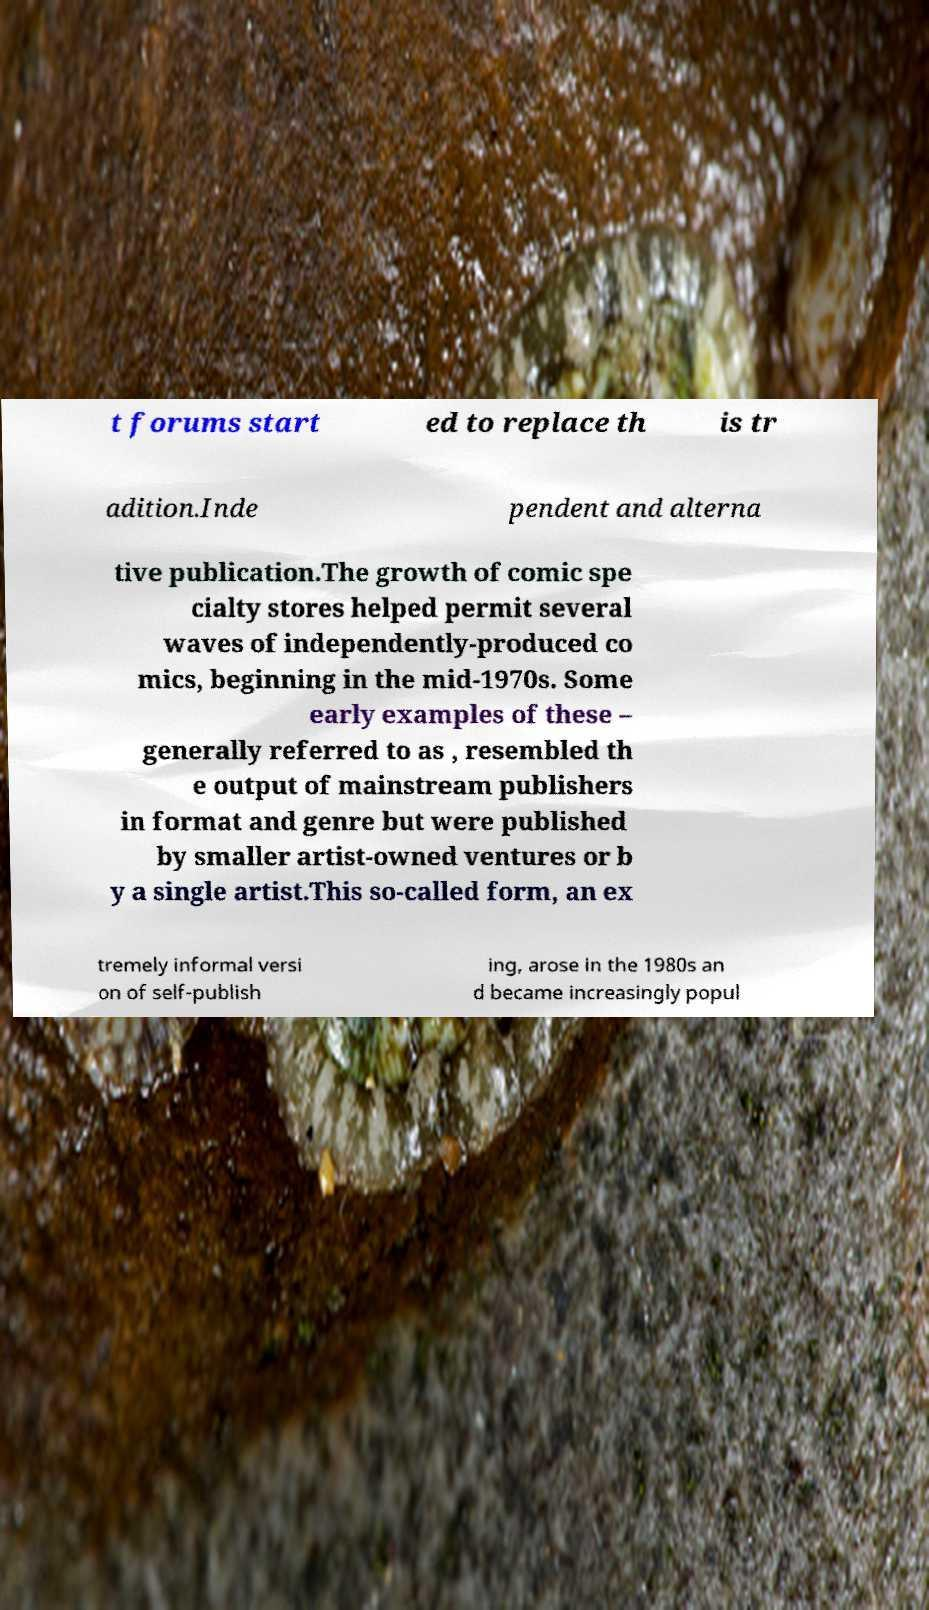Please identify and transcribe the text found in this image. t forums start ed to replace th is tr adition.Inde pendent and alterna tive publication.The growth of comic spe cialty stores helped permit several waves of independently-produced co mics, beginning in the mid-1970s. Some early examples of these – generally referred to as , resembled th e output of mainstream publishers in format and genre but were published by smaller artist-owned ventures or b y a single artist.This so-called form, an ex tremely informal versi on of self-publish ing, arose in the 1980s an d became increasingly popul 